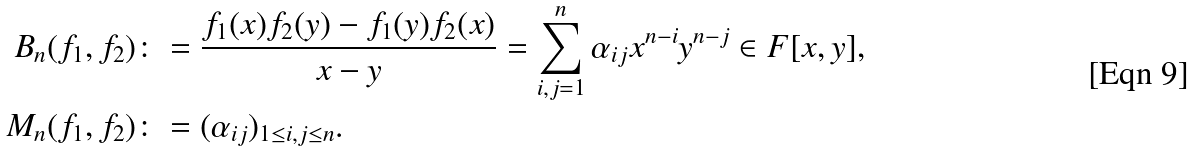Convert formula to latex. <formula><loc_0><loc_0><loc_500><loc_500>B _ { n } ( f _ { 1 } , f _ { 2 } ) \colon & = \frac { f _ { 1 } ( x ) f _ { 2 } ( y ) - f _ { 1 } ( y ) f _ { 2 } ( x ) } { x - y } = \sum _ { i , j = 1 } ^ { n } \alpha _ { i j } x ^ { n - i } y ^ { n - j } \in F [ x , y ] , \\ M _ { n } ( f _ { 1 } , f _ { 2 } ) \colon & = ( \alpha _ { i j } ) _ { 1 \leq i , j \leq n } .</formula> 